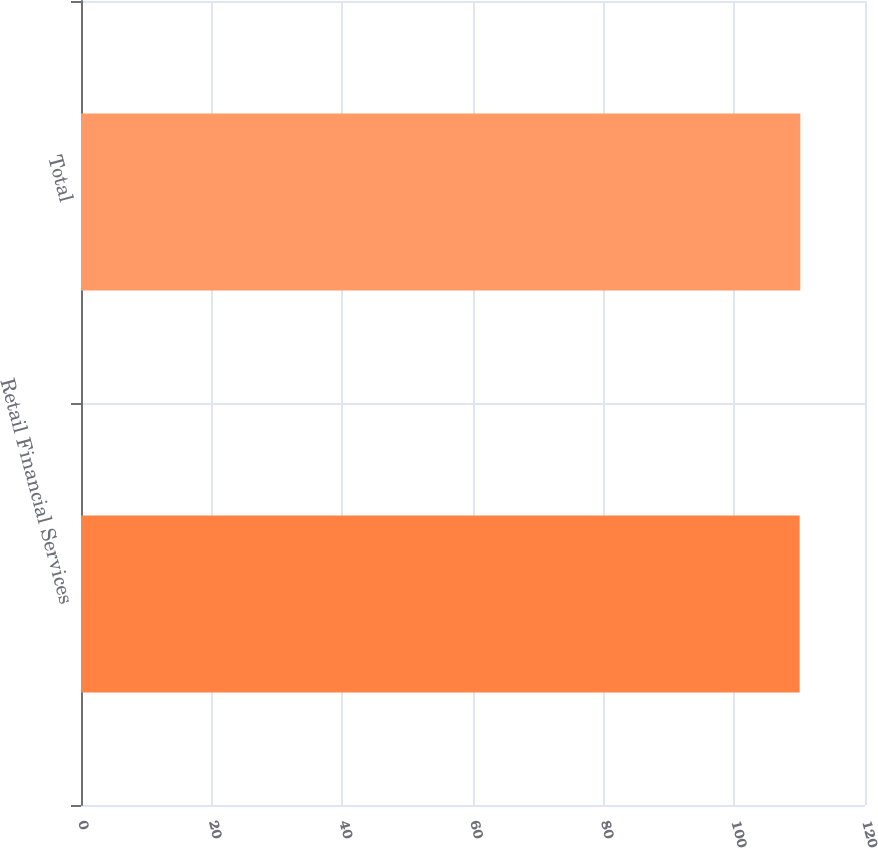Convert chart to OTSL. <chart><loc_0><loc_0><loc_500><loc_500><bar_chart><fcel>Retail Financial Services<fcel>Total<nl><fcel>110<fcel>110.1<nl></chart> 